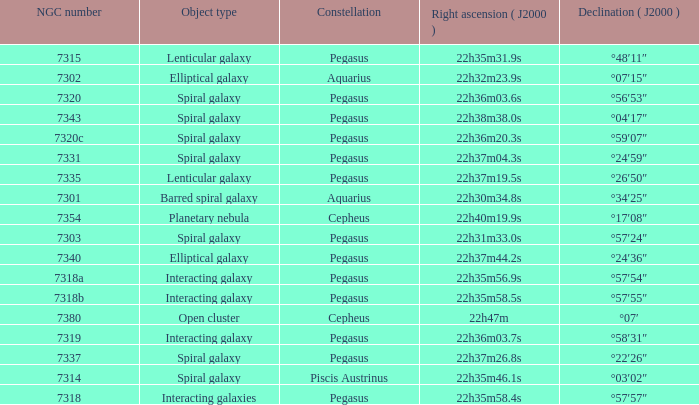What is the declination of the spiral galaxy Pegasus with 7337 NGC °22′26″. 